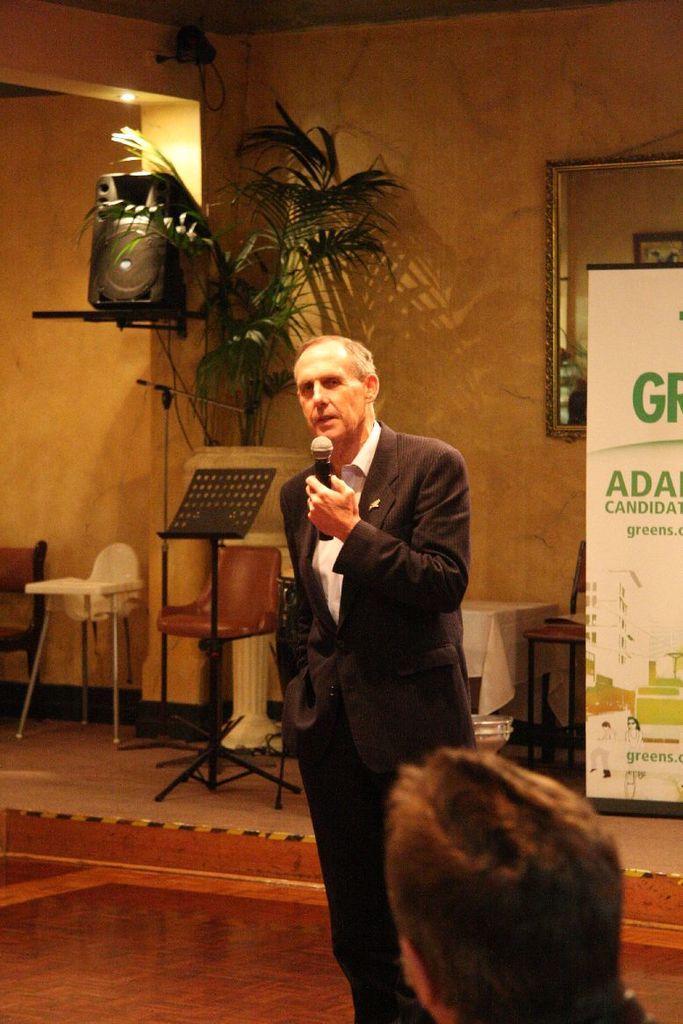In one or two sentences, can you explain what this image depicts? This man wore black suit and holding a mic. On top there is a sound box. Beside this sound box there is a plant. These are chairs. This is a white banner. A mirror on wall. A table with cloth. 